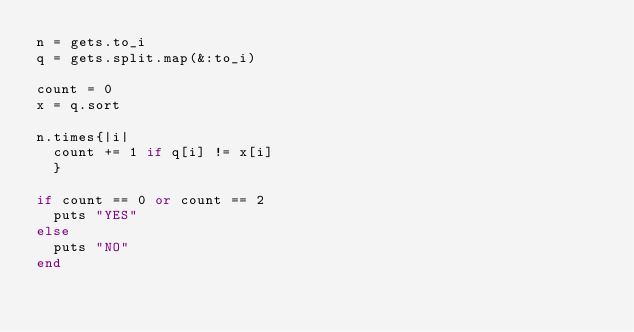<code> <loc_0><loc_0><loc_500><loc_500><_Ruby_>n = gets.to_i
q = gets.split.map(&:to_i)
 
count = 0
x = q.sort
 
n.times{|i|
  count += 1 if q[i] != x[i]
  }
 
if count == 0 or count == 2
  puts "YES"
else
  puts "NO"
end</code> 